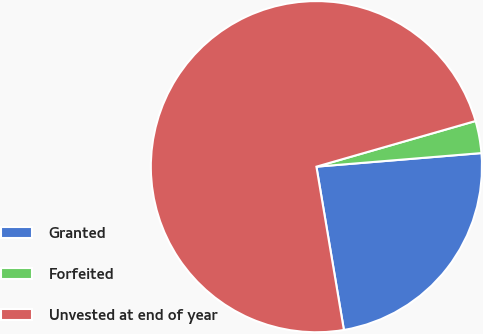Convert chart. <chart><loc_0><loc_0><loc_500><loc_500><pie_chart><fcel>Granted<fcel>Forfeited<fcel>Unvested at end of year<nl><fcel>23.65%<fcel>3.14%<fcel>73.2%<nl></chart> 